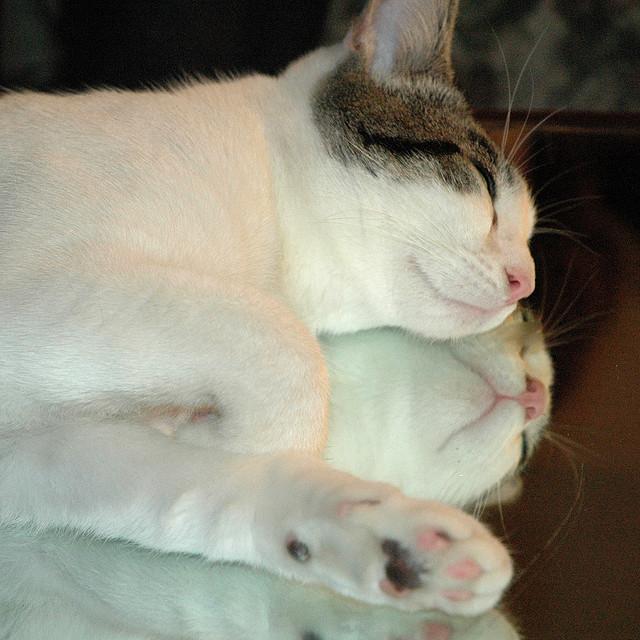Is the cat jumping?
Answer briefly. No. Is the cat looking at the camera?
Short answer required. No. Are they sleeping?
Write a very short answer. Yes. Is the cat sleeping?
Concise answer only. Yes. Is the animal happy?
Concise answer only. Yes. What is the cat laying on?
Keep it brief. Mirror. What color is the cat''s fur?
Concise answer only. White. Does it appear to be two cats?
Concise answer only. Yes. Does the cat look angry?
Short answer required. No. What type of cat does this appear to be?
Concise answer only. House. What animal is pictured?
Short answer required. Cat. Is the cat asleep?
Concise answer only. Yes. How many spots does the cat have?
Give a very brief answer. 0. 